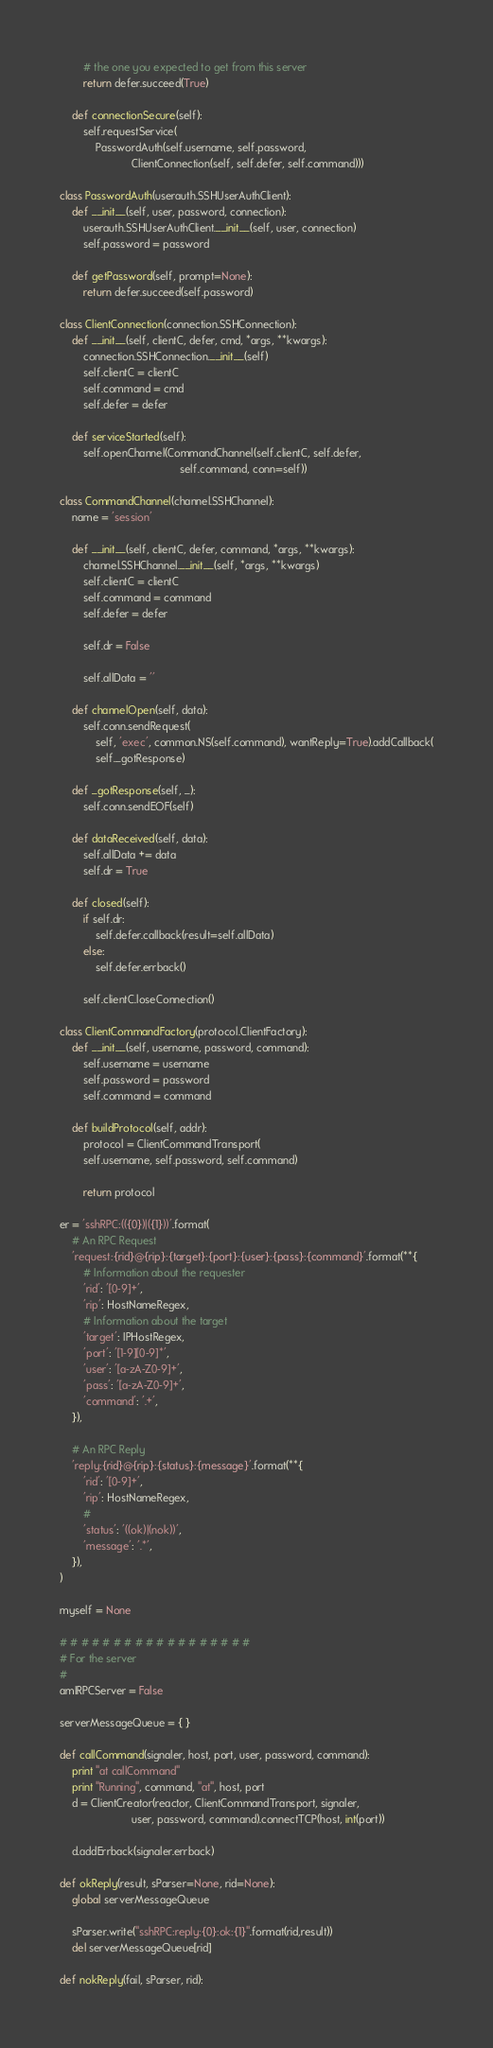<code> <loc_0><loc_0><loc_500><loc_500><_Python_>		# the one you expected to get from this server
		return defer.succeed(True)

	def connectionSecure(self):
		self.requestService(
			PasswordAuth(self.username, self.password,
						ClientConnection(self, self.defer, self.command)))

class PasswordAuth(userauth.SSHUserAuthClient):
	def __init__(self, user, password, connection):
		userauth.SSHUserAuthClient.__init__(self, user, connection)
		self.password = password

	def getPassword(self, prompt=None):
		return defer.succeed(self.password)

class ClientConnection(connection.SSHConnection):
	def __init__(self, clientC, defer, cmd, *args, **kwargs):
		connection.SSHConnection.__init__(self)
		self.clientC = clientC
		self.command = cmd
		self.defer = defer

	def serviceStarted(self):
		self.openChannel(CommandChannel(self.clientC, self.defer,
										self.command, conn=self))

class CommandChannel(channel.SSHChannel):
	name = 'session'

	def __init__(self, clientC, defer, command, *args, **kwargs):
		channel.SSHChannel.__init__(self, *args, **kwargs)
		self.clientC = clientC
		self.command = command
		self.defer = defer

		self.dr = False

		self.allData = ''

	def channelOpen(self, data):
		self.conn.sendRequest(
			self, 'exec', common.NS(self.command), wantReply=True).addCallback(
			self._gotResponse)

	def _gotResponse(self, _):
		self.conn.sendEOF(self)

	def dataReceived(self, data):
		self.allData += data
		self.dr = True

	def closed(self):
		if self.dr:
			self.defer.callback(result=self.allData)
		else:
			self.defer.errback()

		self.clientC.loseConnection()

class ClientCommandFactory(protocol.ClientFactory):
	def __init__(self, username, password, command):
		self.username = username
		self.password = password
		self.command = command

	def buildProtocol(self, addr):
		protocol = ClientCommandTransport(
		self.username, self.password, self.command)

		return protocol

er = 'sshRPC:(({0})|({1}))'.format(
	# An RPC Request
	'request:{rid}@{rip}:{target}:{port}:{user}:{pass}:{command}'.format(**{
		# Information about the requester
		'rid': '[0-9]+',
		'rip': HostNameRegex,
		# Information about the target
		'target': IPHostRegex,
		'port': '[1-9][0-9]*',
		'user': '[a-zA-Z0-9]+',
		'pass': '[a-zA-Z0-9]+',
		'command': '.+',
	}),

	# An RPC Reply
	'reply:{rid}@{rip}:{status}:{message}'.format(**{
		'rid': '[0-9]+',
		'rip': HostNameRegex,
		#
		'status': '((ok)|(nok))',
		'message': '.*',
	}),
)

myself = None

# # # # # # # # # # # # # # # # # #
# For the server
#
amIRPCServer = False

serverMessageQueue = { }

def callCommand(signaler, host, port, user, password, command):
	print "at callCommand"
	print "Running", command, "at", host, port
	d = ClientCreator(reactor, ClientCommandTransport, signaler,
						user, password, command).connectTCP(host, int(port))

	d.addErrback(signaler.errback)

def okReply(result, sParser=None, rid=None):
	global serverMessageQueue

	sParser.write("sshRPC:reply:{0}:ok:{1}".format(rid,result))
	del serverMessageQueue[rid]

def nokReply(fail, sParser, rid):</code> 